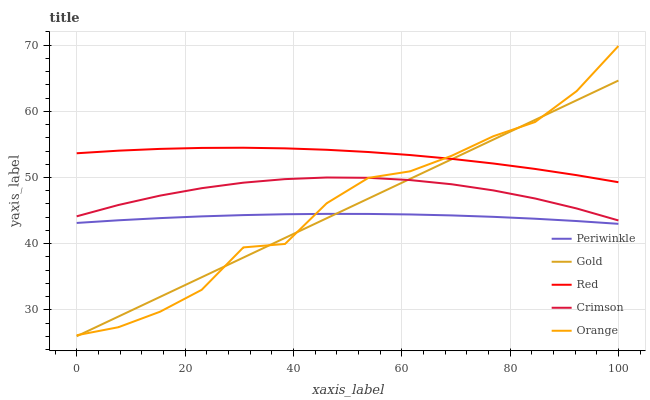Does Orange have the minimum area under the curve?
Answer yes or no. No. Does Orange have the maximum area under the curve?
Answer yes or no. No. Is Periwinkle the smoothest?
Answer yes or no. No. Is Periwinkle the roughest?
Answer yes or no. No. Does Orange have the lowest value?
Answer yes or no. No. Does Periwinkle have the highest value?
Answer yes or no. No. Is Crimson less than Red?
Answer yes or no. Yes. Is Red greater than Crimson?
Answer yes or no. Yes. Does Crimson intersect Red?
Answer yes or no. No. 